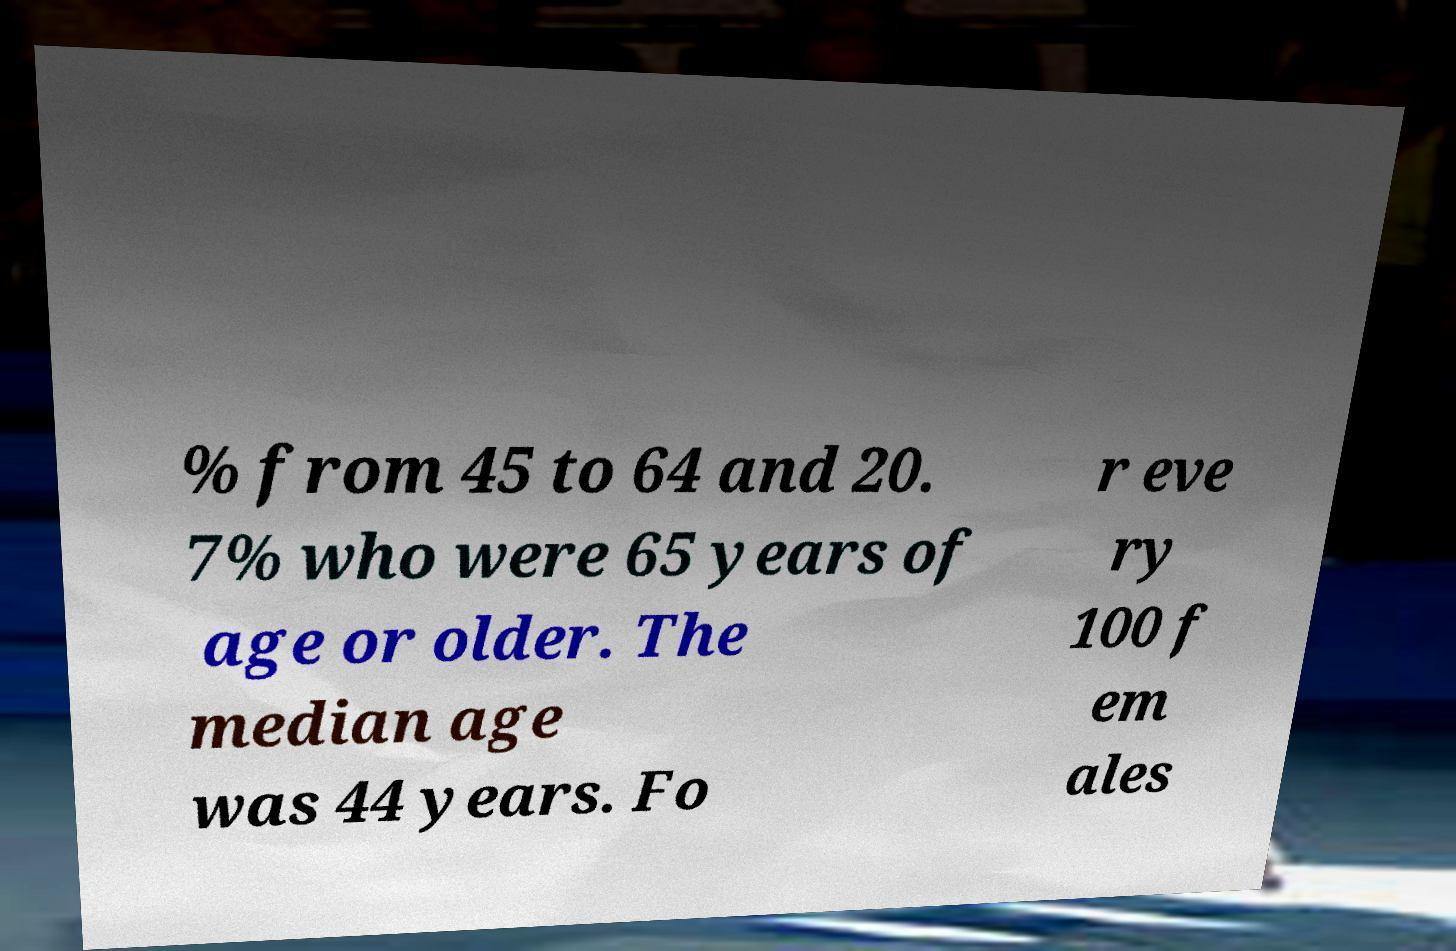For documentation purposes, I need the text within this image transcribed. Could you provide that? % from 45 to 64 and 20. 7% who were 65 years of age or older. The median age was 44 years. Fo r eve ry 100 f em ales 